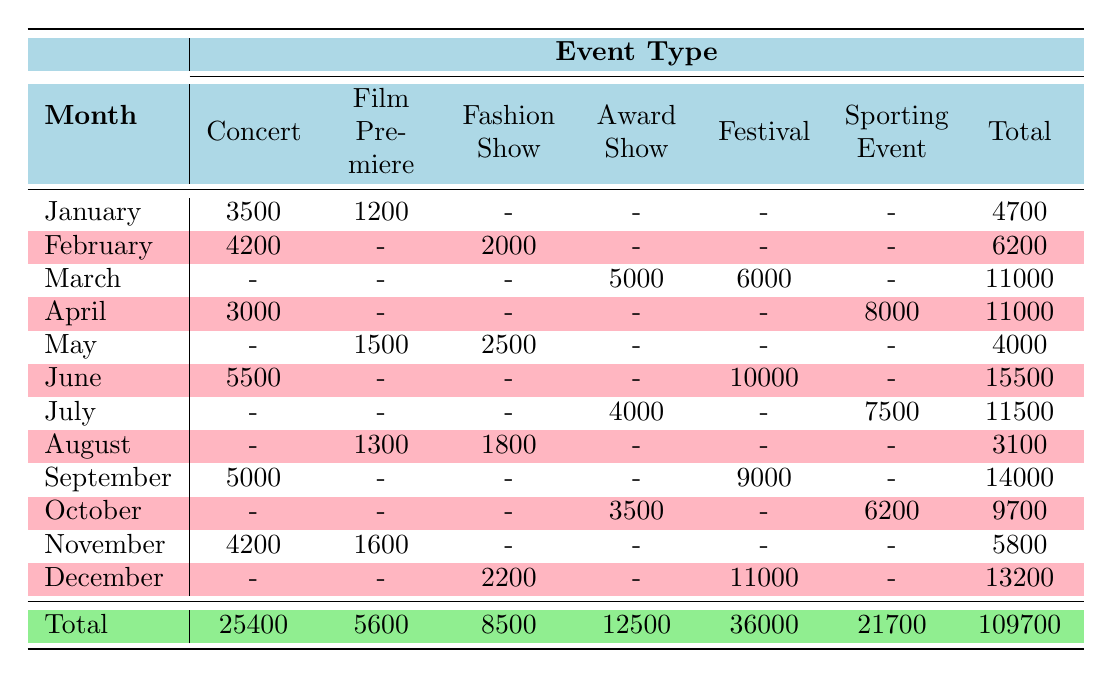What was the total attendance for Concerts in June? The attendance for Concerts in June is listed as 5500, and since there are no other entries for Concerts in June, the total attendance for this event type in that month is 5500.
Answer: 5500 How many people attended Award Shows in March? For March, the attendance for the Award Show is specifically mentioned as 5000, and that is the total as there is only one entry for this event type in that month.
Answer: 5000 What is the total attendance for Festivals across all months? To find the total attendance for Festivals, we sum up the attendance values from all relevant months: March (6000), June (10000), September (9000), and December (11000). Thus, the total is 6000 + 10000 + 9000 + 11000 = 36000.
Answer: 36000 Was the attendance for Sporting Events in April more than that in October? The attendance for Sporting Events is 8000 for April and 6200 for October. Since 8000 is greater than 6200, the statement is true.
Answer: Yes What month had the highest attendance overall, and what was that attendance? By reviewing the total attendance for each month, we find June had the highest total of 15500. No other month exceeds this value, identifying June as the month with the highest attendance.
Answer: June, 15500 How does the attendance at Fashion Shows in May compare to Film Premieres in the same month? The attendance for Fashion Shows in May is 2500, while for Film Premieres it is 1500. Comparing these numbers, we see that the attendance for Fashion Shows is greater than that for Film Premieres in that month.
Answer: Fashion Shows has more attendance What was the average attendance for Award Shows across the year? Award Shows took place in March (5000), July (4000), and October (3500). To find the average, we first sum the attendances: 5000 + 4000 + 3500 = 12500. This total is divided by 3 (the number of events) to find the average, which results in 12500 / 3 = 4166.67.
Answer: 4166.67 Was there any month where no Concerts took place? Looking at the table, we can see that August and November have entries for other event types but no entry for Concerts. This confirms that there were indeed months without any Concerts.
Answer: Yes Which month had the second highest total attendance? The total attendances are as follows: January (4700), February (6200), March (11000), April (11000), May (4000), June (15500), July (11500), August (3100), September (14000), October (9700), November (5800), December (13200). By sorting these, we find that December has the second highest attendance of 13200.
Answer: December, 13200 